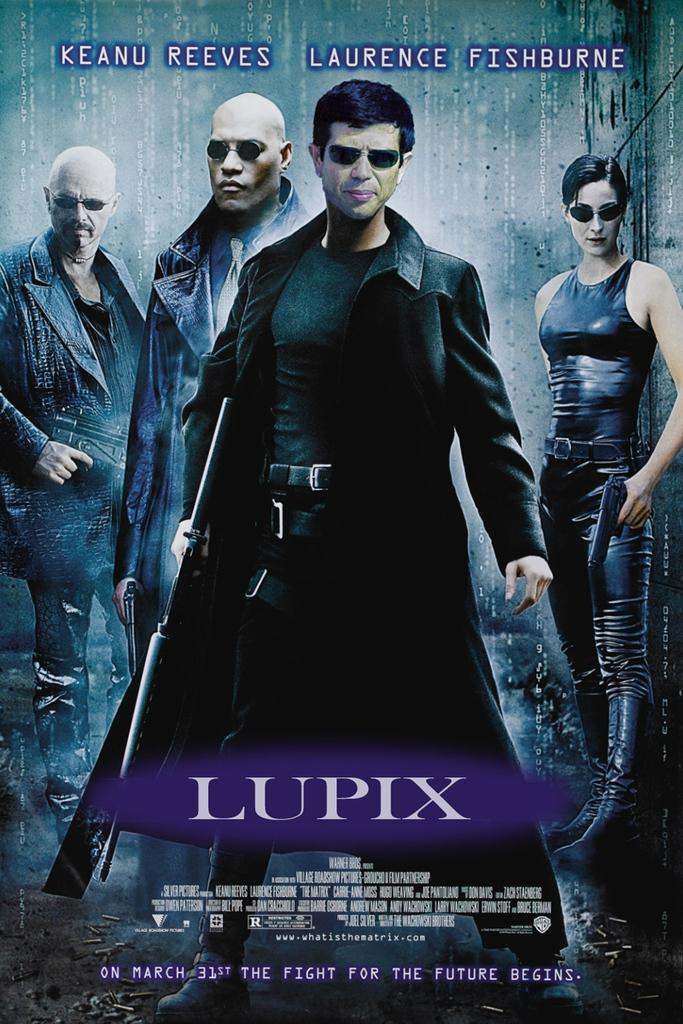What can be seen hanging on the wall in the image? There is a poster in the image. How many people are present in the image? Four people are standing in the image. What are the people wearing on their heads? The people are wearing goggles. What color are the dresses worn by the people? The people are wearing black dresses. What is written at the top and bottom of the image? There is text written at the top and bottom of the image. What type of apparatus is being used by the beggar in the image? There is no beggar present in the image, and therefore no apparatus can be associated with them. How many mice can be seen running around the people's feet in the image? There are no mice present in the image; the people are wearing goggles and black dresses. 